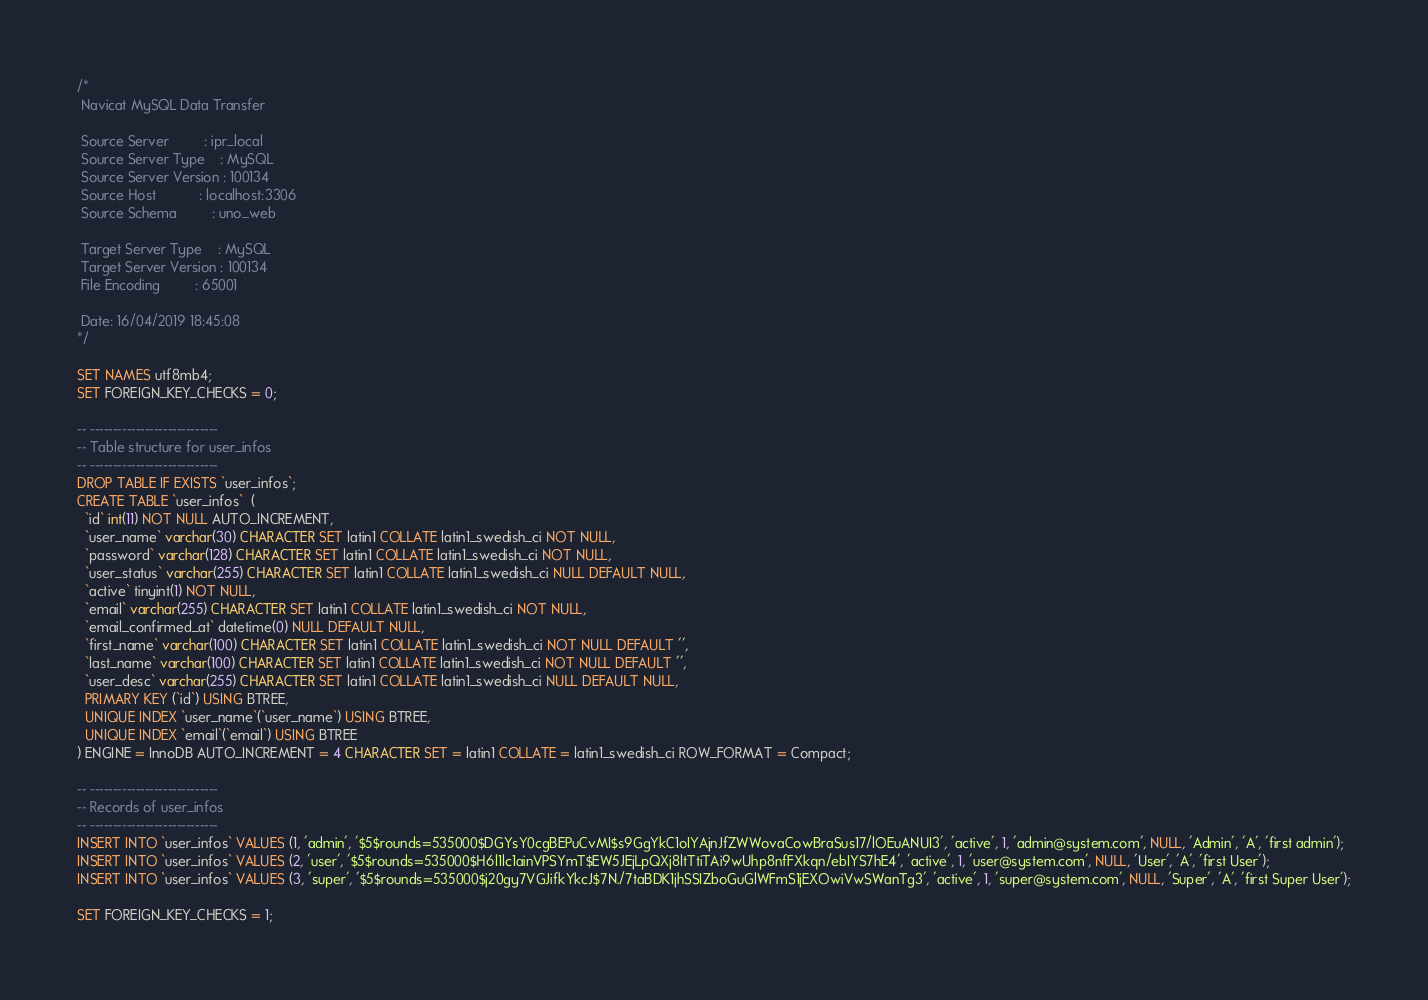<code> <loc_0><loc_0><loc_500><loc_500><_SQL_>/*
 Navicat MySQL Data Transfer

 Source Server         : ipr_local
 Source Server Type    : MySQL
 Source Server Version : 100134
 Source Host           : localhost:3306
 Source Schema         : uno_web

 Target Server Type    : MySQL
 Target Server Version : 100134
 File Encoding         : 65001

 Date: 16/04/2019 18:45:08
*/

SET NAMES utf8mb4;
SET FOREIGN_KEY_CHECKS = 0;

-- ----------------------------
-- Table structure for user_infos
-- ----------------------------
DROP TABLE IF EXISTS `user_infos`;
CREATE TABLE `user_infos`  (
  `id` int(11) NOT NULL AUTO_INCREMENT,
  `user_name` varchar(30) CHARACTER SET latin1 COLLATE latin1_swedish_ci NOT NULL,
  `password` varchar(128) CHARACTER SET latin1 COLLATE latin1_swedish_ci NOT NULL,
  `user_status` varchar(255) CHARACTER SET latin1 COLLATE latin1_swedish_ci NULL DEFAULT NULL,
  `active` tinyint(1) NOT NULL,
  `email` varchar(255) CHARACTER SET latin1 COLLATE latin1_swedish_ci NOT NULL,
  `email_confirmed_at` datetime(0) NULL DEFAULT NULL,
  `first_name` varchar(100) CHARACTER SET latin1 COLLATE latin1_swedish_ci NOT NULL DEFAULT '',
  `last_name` varchar(100) CHARACTER SET latin1 COLLATE latin1_swedish_ci NOT NULL DEFAULT '',
  `user_desc` varchar(255) CHARACTER SET latin1 COLLATE latin1_swedish_ci NULL DEFAULT NULL,
  PRIMARY KEY (`id`) USING BTREE,
  UNIQUE INDEX `user_name`(`user_name`) USING BTREE,
  UNIQUE INDEX `email`(`email`) USING BTREE
) ENGINE = InnoDB AUTO_INCREMENT = 4 CHARACTER SET = latin1 COLLATE = latin1_swedish_ci ROW_FORMAT = Compact;

-- ----------------------------
-- Records of user_infos
-- ----------------------------
INSERT INTO `user_infos` VALUES (1, 'admin', '$5$rounds=535000$DGYsY0cgBEPuCvMI$s9GgYkC1oIYAjnJfZWWovaCowBraSus17/lOEuANUI3', 'active', 1, 'admin@system.com', NULL, 'Admin', 'A', 'first admin');
INSERT INTO `user_infos` VALUES (2, 'user', '$5$rounds=535000$H6l1lc1ainVPSYmT$EW5JEjLpQXj8ltTtiTAi9wUhp8nfFXkqn/ebIYS7hE4', 'active', 1, 'user@system.com', NULL, 'User', 'A', 'first User');
INSERT INTO `user_infos` VALUES (3, 'super', '$5$rounds=535000$j20gy7VGJifkYkcJ$7N./7taBDK1jhSSIZboGuGlWFmS1jEXOwiVwSWanTg3', 'active', 1, 'super@system.com', NULL, 'Super', 'A', 'first Super User');

SET FOREIGN_KEY_CHECKS = 1;
</code> 